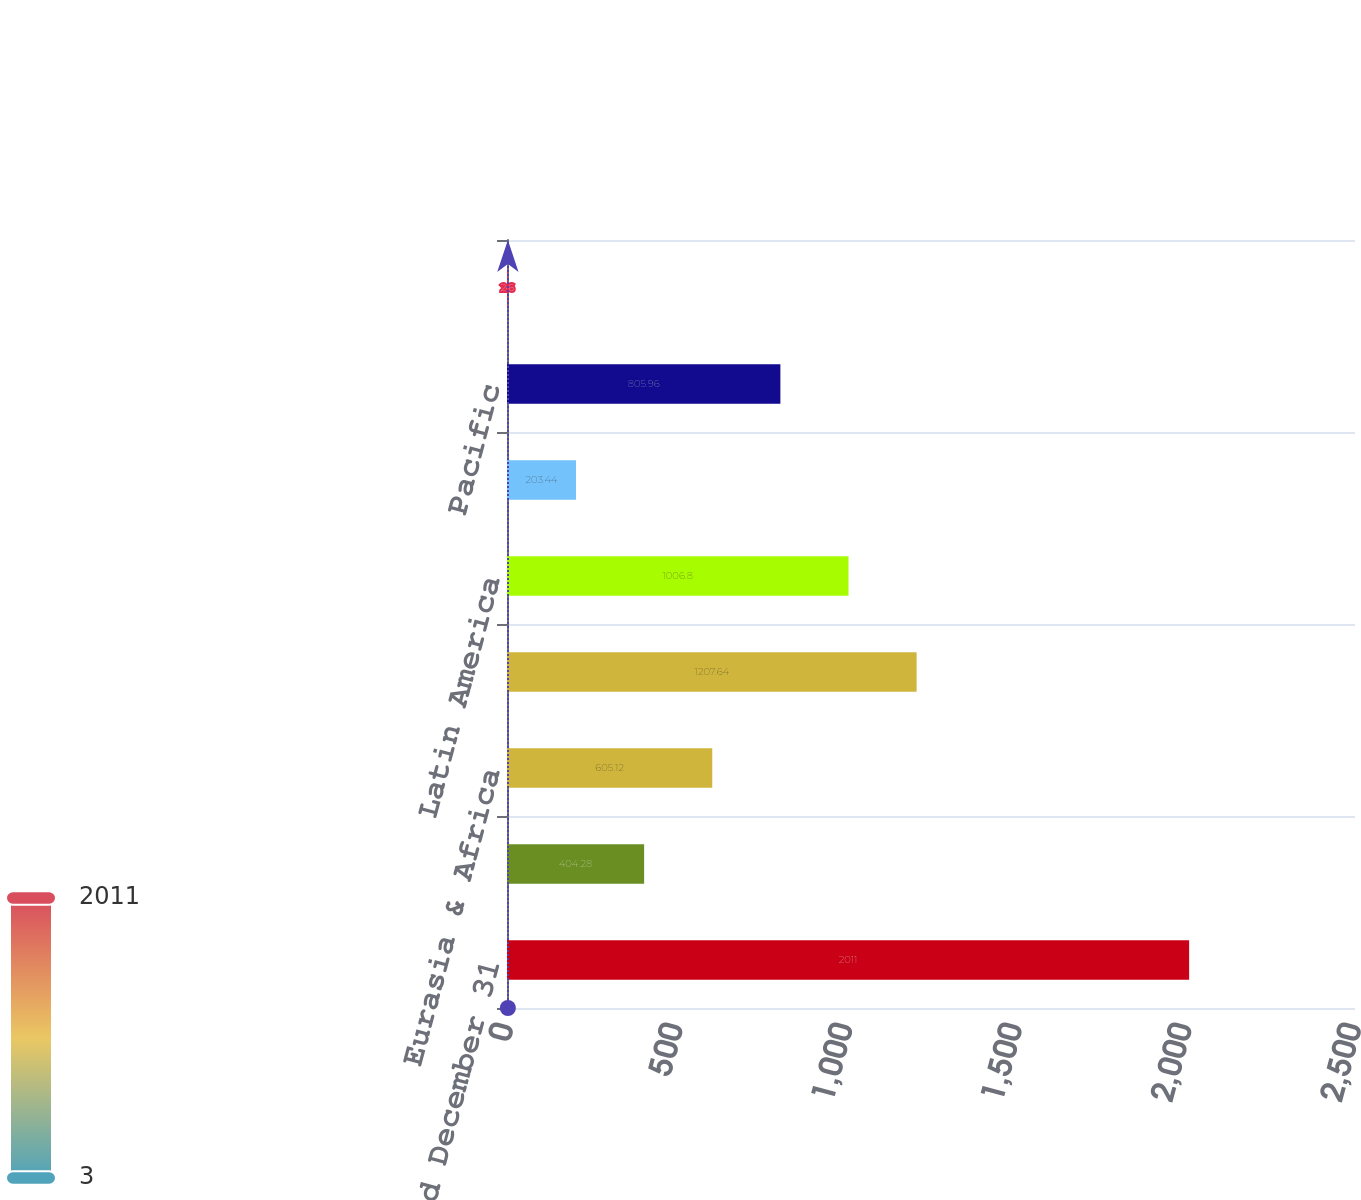<chart> <loc_0><loc_0><loc_500><loc_500><bar_chart><fcel>Year Ended December 31<fcel>Consolidated<fcel>Eurasia & Africa<fcel>Europe<fcel>Latin America<fcel>North America<fcel>Pacific<fcel>Bottling Investments<nl><fcel>2011<fcel>404.28<fcel>605.12<fcel>1207.64<fcel>1006.8<fcel>203.44<fcel>805.96<fcel>2.6<nl></chart> 